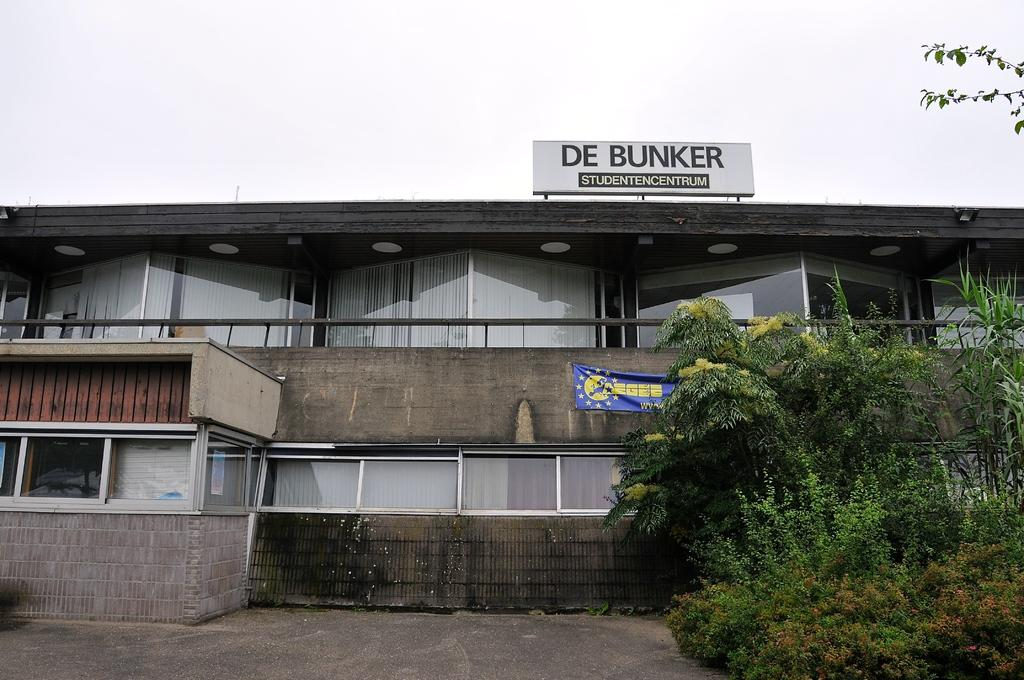What type of structure is present in the image? There is a building in the image. What can be seen in the background of the image? There are trees visible in the image. What is written on the building? There is a name board on the building. What additional signage is present in the image? There is a banner in the image. How would you describe the weather based on the image? The sky is cloudy in the image. What type of window treatment is visible on the building? There are blinds on the windows. What type of tax is being discussed on the observation deck in the image? There is no observation deck or tax discussion present in the image. 